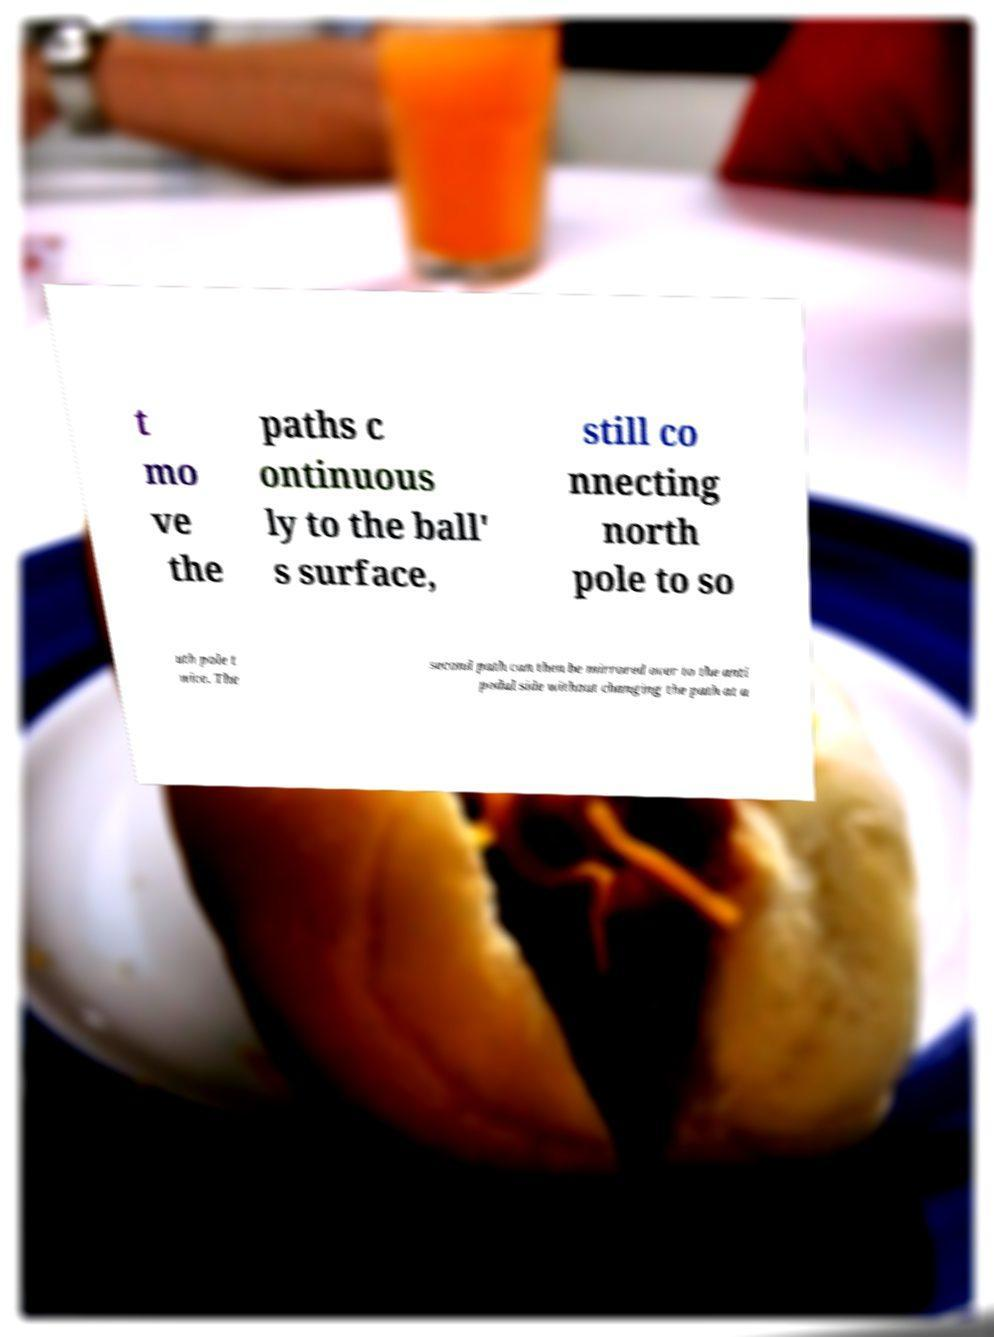What messages or text are displayed in this image? I need them in a readable, typed format. t mo ve the paths c ontinuous ly to the ball' s surface, still co nnecting north pole to so uth pole t wice. The second path can then be mirrored over to the anti podal side without changing the path at a 